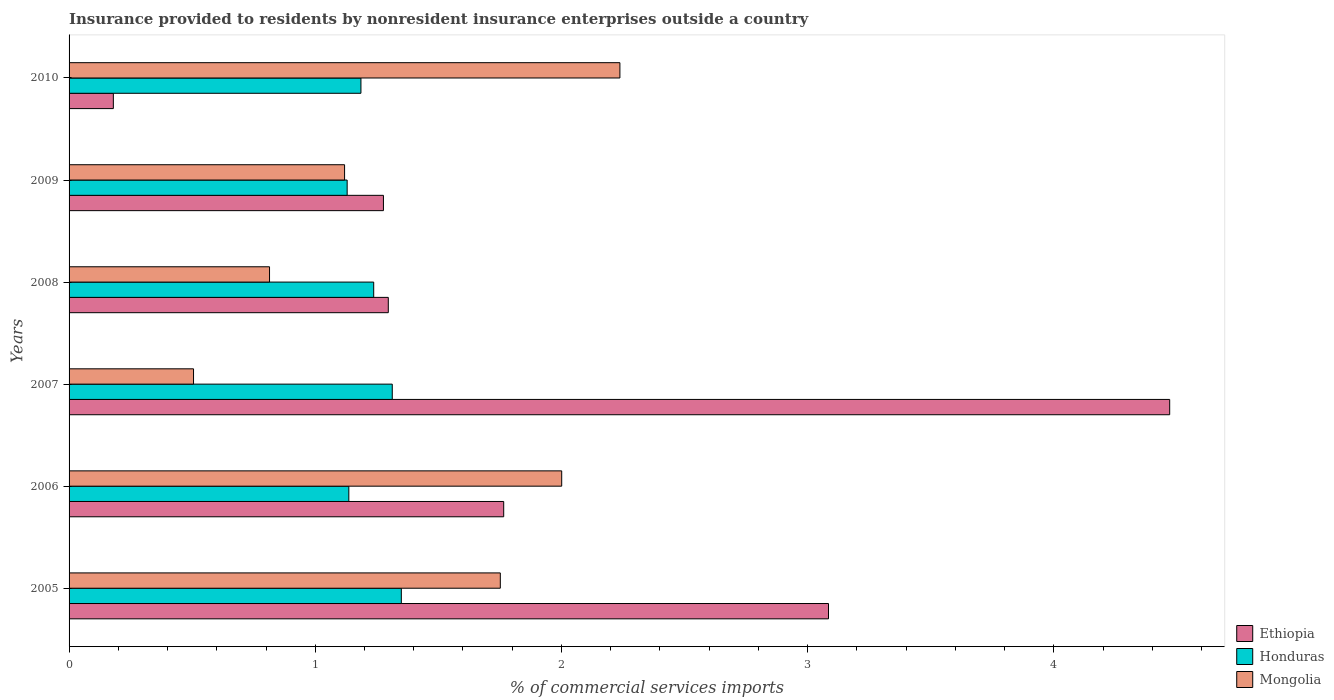How many groups of bars are there?
Your answer should be very brief. 6. Are the number of bars per tick equal to the number of legend labels?
Your answer should be very brief. Yes. In how many cases, is the number of bars for a given year not equal to the number of legend labels?
Your answer should be very brief. 0. What is the Insurance provided to residents in Honduras in 2005?
Your answer should be compact. 1.35. Across all years, what is the maximum Insurance provided to residents in Ethiopia?
Your answer should be compact. 4.47. Across all years, what is the minimum Insurance provided to residents in Ethiopia?
Provide a succinct answer. 0.18. In which year was the Insurance provided to residents in Ethiopia maximum?
Make the answer very short. 2007. In which year was the Insurance provided to residents in Honduras minimum?
Give a very brief answer. 2009. What is the total Insurance provided to residents in Ethiopia in the graph?
Ensure brevity in your answer.  12.07. What is the difference between the Insurance provided to residents in Mongolia in 2006 and that in 2007?
Your answer should be compact. 1.5. What is the difference between the Insurance provided to residents in Ethiopia in 2005 and the Insurance provided to residents in Honduras in 2008?
Provide a succinct answer. 1.85. What is the average Insurance provided to residents in Honduras per year?
Keep it short and to the point. 1.23. In the year 2006, what is the difference between the Insurance provided to residents in Mongolia and Insurance provided to residents in Honduras?
Provide a short and direct response. 0.86. In how many years, is the Insurance provided to residents in Ethiopia greater than 3 %?
Your answer should be very brief. 2. What is the ratio of the Insurance provided to residents in Mongolia in 2005 to that in 2009?
Your answer should be very brief. 1.57. What is the difference between the highest and the second highest Insurance provided to residents in Honduras?
Give a very brief answer. 0.04. What is the difference between the highest and the lowest Insurance provided to residents in Ethiopia?
Your response must be concise. 4.29. What does the 3rd bar from the top in 2009 represents?
Offer a terse response. Ethiopia. What does the 1st bar from the bottom in 2009 represents?
Give a very brief answer. Ethiopia. Is it the case that in every year, the sum of the Insurance provided to residents in Honduras and Insurance provided to residents in Mongolia is greater than the Insurance provided to residents in Ethiopia?
Your response must be concise. No. How many bars are there?
Offer a very short reply. 18. How many years are there in the graph?
Your response must be concise. 6. What is the difference between two consecutive major ticks on the X-axis?
Provide a succinct answer. 1. Are the values on the major ticks of X-axis written in scientific E-notation?
Offer a terse response. No. What is the title of the graph?
Keep it short and to the point. Insurance provided to residents by nonresident insurance enterprises outside a country. Does "Afghanistan" appear as one of the legend labels in the graph?
Give a very brief answer. No. What is the label or title of the X-axis?
Your response must be concise. % of commercial services imports. What is the % of commercial services imports of Ethiopia in 2005?
Ensure brevity in your answer.  3.08. What is the % of commercial services imports in Honduras in 2005?
Give a very brief answer. 1.35. What is the % of commercial services imports in Mongolia in 2005?
Give a very brief answer. 1.75. What is the % of commercial services imports in Ethiopia in 2006?
Provide a short and direct response. 1.77. What is the % of commercial services imports of Honduras in 2006?
Ensure brevity in your answer.  1.14. What is the % of commercial services imports of Mongolia in 2006?
Keep it short and to the point. 2. What is the % of commercial services imports in Ethiopia in 2007?
Offer a terse response. 4.47. What is the % of commercial services imports in Honduras in 2007?
Make the answer very short. 1.31. What is the % of commercial services imports in Mongolia in 2007?
Offer a very short reply. 0.51. What is the % of commercial services imports in Ethiopia in 2008?
Provide a short and direct response. 1.3. What is the % of commercial services imports in Honduras in 2008?
Keep it short and to the point. 1.24. What is the % of commercial services imports in Mongolia in 2008?
Make the answer very short. 0.81. What is the % of commercial services imports in Ethiopia in 2009?
Provide a succinct answer. 1.28. What is the % of commercial services imports of Honduras in 2009?
Your answer should be compact. 1.13. What is the % of commercial services imports of Mongolia in 2009?
Offer a very short reply. 1.12. What is the % of commercial services imports in Ethiopia in 2010?
Provide a short and direct response. 0.18. What is the % of commercial services imports in Honduras in 2010?
Your answer should be very brief. 1.19. What is the % of commercial services imports in Mongolia in 2010?
Your answer should be compact. 2.24. Across all years, what is the maximum % of commercial services imports of Ethiopia?
Your answer should be compact. 4.47. Across all years, what is the maximum % of commercial services imports of Honduras?
Provide a succinct answer. 1.35. Across all years, what is the maximum % of commercial services imports in Mongolia?
Give a very brief answer. 2.24. Across all years, what is the minimum % of commercial services imports in Ethiopia?
Your answer should be compact. 0.18. Across all years, what is the minimum % of commercial services imports of Honduras?
Offer a terse response. 1.13. Across all years, what is the minimum % of commercial services imports of Mongolia?
Provide a succinct answer. 0.51. What is the total % of commercial services imports in Ethiopia in the graph?
Offer a very short reply. 12.07. What is the total % of commercial services imports of Honduras in the graph?
Make the answer very short. 7.35. What is the total % of commercial services imports in Mongolia in the graph?
Your answer should be very brief. 8.43. What is the difference between the % of commercial services imports in Ethiopia in 2005 and that in 2006?
Your answer should be very brief. 1.32. What is the difference between the % of commercial services imports in Honduras in 2005 and that in 2006?
Your response must be concise. 0.21. What is the difference between the % of commercial services imports of Mongolia in 2005 and that in 2006?
Provide a short and direct response. -0.25. What is the difference between the % of commercial services imports of Ethiopia in 2005 and that in 2007?
Make the answer very short. -1.39. What is the difference between the % of commercial services imports of Honduras in 2005 and that in 2007?
Offer a very short reply. 0.04. What is the difference between the % of commercial services imports in Mongolia in 2005 and that in 2007?
Provide a short and direct response. 1.25. What is the difference between the % of commercial services imports in Ethiopia in 2005 and that in 2008?
Make the answer very short. 1.79. What is the difference between the % of commercial services imports of Honduras in 2005 and that in 2008?
Give a very brief answer. 0.11. What is the difference between the % of commercial services imports in Mongolia in 2005 and that in 2008?
Make the answer very short. 0.94. What is the difference between the % of commercial services imports in Ethiopia in 2005 and that in 2009?
Provide a succinct answer. 1.81. What is the difference between the % of commercial services imports of Honduras in 2005 and that in 2009?
Keep it short and to the point. 0.22. What is the difference between the % of commercial services imports of Mongolia in 2005 and that in 2009?
Make the answer very short. 0.63. What is the difference between the % of commercial services imports of Ethiopia in 2005 and that in 2010?
Provide a short and direct response. 2.9. What is the difference between the % of commercial services imports in Honduras in 2005 and that in 2010?
Provide a succinct answer. 0.16. What is the difference between the % of commercial services imports of Mongolia in 2005 and that in 2010?
Give a very brief answer. -0.49. What is the difference between the % of commercial services imports of Ethiopia in 2006 and that in 2007?
Your answer should be compact. -2.71. What is the difference between the % of commercial services imports of Honduras in 2006 and that in 2007?
Your answer should be compact. -0.18. What is the difference between the % of commercial services imports of Mongolia in 2006 and that in 2007?
Provide a short and direct response. 1.5. What is the difference between the % of commercial services imports in Ethiopia in 2006 and that in 2008?
Ensure brevity in your answer.  0.47. What is the difference between the % of commercial services imports in Honduras in 2006 and that in 2008?
Ensure brevity in your answer.  -0.1. What is the difference between the % of commercial services imports in Mongolia in 2006 and that in 2008?
Offer a terse response. 1.19. What is the difference between the % of commercial services imports in Ethiopia in 2006 and that in 2009?
Offer a very short reply. 0.49. What is the difference between the % of commercial services imports of Honduras in 2006 and that in 2009?
Your answer should be very brief. 0.01. What is the difference between the % of commercial services imports in Mongolia in 2006 and that in 2009?
Keep it short and to the point. 0.88. What is the difference between the % of commercial services imports in Ethiopia in 2006 and that in 2010?
Your response must be concise. 1.59. What is the difference between the % of commercial services imports in Honduras in 2006 and that in 2010?
Provide a succinct answer. -0.05. What is the difference between the % of commercial services imports of Mongolia in 2006 and that in 2010?
Offer a very short reply. -0.24. What is the difference between the % of commercial services imports of Ethiopia in 2007 and that in 2008?
Your answer should be compact. 3.17. What is the difference between the % of commercial services imports of Honduras in 2007 and that in 2008?
Offer a terse response. 0.08. What is the difference between the % of commercial services imports of Mongolia in 2007 and that in 2008?
Keep it short and to the point. -0.31. What is the difference between the % of commercial services imports of Ethiopia in 2007 and that in 2009?
Offer a terse response. 3.19. What is the difference between the % of commercial services imports in Honduras in 2007 and that in 2009?
Provide a succinct answer. 0.18. What is the difference between the % of commercial services imports in Mongolia in 2007 and that in 2009?
Offer a terse response. -0.61. What is the difference between the % of commercial services imports in Ethiopia in 2007 and that in 2010?
Provide a short and direct response. 4.29. What is the difference between the % of commercial services imports of Honduras in 2007 and that in 2010?
Ensure brevity in your answer.  0.13. What is the difference between the % of commercial services imports in Mongolia in 2007 and that in 2010?
Ensure brevity in your answer.  -1.73. What is the difference between the % of commercial services imports in Ethiopia in 2008 and that in 2009?
Give a very brief answer. 0.02. What is the difference between the % of commercial services imports in Honduras in 2008 and that in 2009?
Offer a very short reply. 0.11. What is the difference between the % of commercial services imports in Mongolia in 2008 and that in 2009?
Make the answer very short. -0.3. What is the difference between the % of commercial services imports in Ethiopia in 2008 and that in 2010?
Your response must be concise. 1.12. What is the difference between the % of commercial services imports of Honduras in 2008 and that in 2010?
Ensure brevity in your answer.  0.05. What is the difference between the % of commercial services imports of Mongolia in 2008 and that in 2010?
Offer a very short reply. -1.42. What is the difference between the % of commercial services imports of Ethiopia in 2009 and that in 2010?
Ensure brevity in your answer.  1.1. What is the difference between the % of commercial services imports in Honduras in 2009 and that in 2010?
Offer a very short reply. -0.06. What is the difference between the % of commercial services imports of Mongolia in 2009 and that in 2010?
Make the answer very short. -1.12. What is the difference between the % of commercial services imports in Ethiopia in 2005 and the % of commercial services imports in Honduras in 2006?
Keep it short and to the point. 1.95. What is the difference between the % of commercial services imports in Ethiopia in 2005 and the % of commercial services imports in Mongolia in 2006?
Your response must be concise. 1.08. What is the difference between the % of commercial services imports of Honduras in 2005 and the % of commercial services imports of Mongolia in 2006?
Keep it short and to the point. -0.65. What is the difference between the % of commercial services imports in Ethiopia in 2005 and the % of commercial services imports in Honduras in 2007?
Provide a short and direct response. 1.77. What is the difference between the % of commercial services imports of Ethiopia in 2005 and the % of commercial services imports of Mongolia in 2007?
Offer a terse response. 2.58. What is the difference between the % of commercial services imports in Honduras in 2005 and the % of commercial services imports in Mongolia in 2007?
Ensure brevity in your answer.  0.84. What is the difference between the % of commercial services imports of Ethiopia in 2005 and the % of commercial services imports of Honduras in 2008?
Provide a succinct answer. 1.85. What is the difference between the % of commercial services imports of Ethiopia in 2005 and the % of commercial services imports of Mongolia in 2008?
Offer a very short reply. 2.27. What is the difference between the % of commercial services imports in Honduras in 2005 and the % of commercial services imports in Mongolia in 2008?
Keep it short and to the point. 0.54. What is the difference between the % of commercial services imports of Ethiopia in 2005 and the % of commercial services imports of Honduras in 2009?
Offer a very short reply. 1.96. What is the difference between the % of commercial services imports of Ethiopia in 2005 and the % of commercial services imports of Mongolia in 2009?
Give a very brief answer. 1.97. What is the difference between the % of commercial services imports in Honduras in 2005 and the % of commercial services imports in Mongolia in 2009?
Your response must be concise. 0.23. What is the difference between the % of commercial services imports in Ethiopia in 2005 and the % of commercial services imports in Honduras in 2010?
Provide a succinct answer. 1.9. What is the difference between the % of commercial services imports of Ethiopia in 2005 and the % of commercial services imports of Mongolia in 2010?
Ensure brevity in your answer.  0.85. What is the difference between the % of commercial services imports in Honduras in 2005 and the % of commercial services imports in Mongolia in 2010?
Provide a short and direct response. -0.89. What is the difference between the % of commercial services imports in Ethiopia in 2006 and the % of commercial services imports in Honduras in 2007?
Your answer should be very brief. 0.45. What is the difference between the % of commercial services imports of Ethiopia in 2006 and the % of commercial services imports of Mongolia in 2007?
Ensure brevity in your answer.  1.26. What is the difference between the % of commercial services imports of Honduras in 2006 and the % of commercial services imports of Mongolia in 2007?
Provide a short and direct response. 0.63. What is the difference between the % of commercial services imports of Ethiopia in 2006 and the % of commercial services imports of Honduras in 2008?
Offer a very short reply. 0.53. What is the difference between the % of commercial services imports in Ethiopia in 2006 and the % of commercial services imports in Mongolia in 2008?
Keep it short and to the point. 0.95. What is the difference between the % of commercial services imports in Honduras in 2006 and the % of commercial services imports in Mongolia in 2008?
Make the answer very short. 0.32. What is the difference between the % of commercial services imports of Ethiopia in 2006 and the % of commercial services imports of Honduras in 2009?
Your answer should be very brief. 0.64. What is the difference between the % of commercial services imports of Ethiopia in 2006 and the % of commercial services imports of Mongolia in 2009?
Your answer should be compact. 0.65. What is the difference between the % of commercial services imports in Honduras in 2006 and the % of commercial services imports in Mongolia in 2009?
Your answer should be compact. 0.02. What is the difference between the % of commercial services imports of Ethiopia in 2006 and the % of commercial services imports of Honduras in 2010?
Your response must be concise. 0.58. What is the difference between the % of commercial services imports of Ethiopia in 2006 and the % of commercial services imports of Mongolia in 2010?
Offer a terse response. -0.47. What is the difference between the % of commercial services imports in Honduras in 2006 and the % of commercial services imports in Mongolia in 2010?
Your answer should be very brief. -1.1. What is the difference between the % of commercial services imports of Ethiopia in 2007 and the % of commercial services imports of Honduras in 2008?
Make the answer very short. 3.23. What is the difference between the % of commercial services imports of Ethiopia in 2007 and the % of commercial services imports of Mongolia in 2008?
Your answer should be very brief. 3.66. What is the difference between the % of commercial services imports of Honduras in 2007 and the % of commercial services imports of Mongolia in 2008?
Ensure brevity in your answer.  0.5. What is the difference between the % of commercial services imports in Ethiopia in 2007 and the % of commercial services imports in Honduras in 2009?
Offer a terse response. 3.34. What is the difference between the % of commercial services imports in Ethiopia in 2007 and the % of commercial services imports in Mongolia in 2009?
Give a very brief answer. 3.35. What is the difference between the % of commercial services imports of Honduras in 2007 and the % of commercial services imports of Mongolia in 2009?
Your response must be concise. 0.19. What is the difference between the % of commercial services imports in Ethiopia in 2007 and the % of commercial services imports in Honduras in 2010?
Offer a terse response. 3.29. What is the difference between the % of commercial services imports in Ethiopia in 2007 and the % of commercial services imports in Mongolia in 2010?
Your response must be concise. 2.23. What is the difference between the % of commercial services imports in Honduras in 2007 and the % of commercial services imports in Mongolia in 2010?
Offer a very short reply. -0.92. What is the difference between the % of commercial services imports in Ethiopia in 2008 and the % of commercial services imports in Honduras in 2009?
Keep it short and to the point. 0.17. What is the difference between the % of commercial services imports of Ethiopia in 2008 and the % of commercial services imports of Mongolia in 2009?
Make the answer very short. 0.18. What is the difference between the % of commercial services imports of Honduras in 2008 and the % of commercial services imports of Mongolia in 2009?
Keep it short and to the point. 0.12. What is the difference between the % of commercial services imports in Ethiopia in 2008 and the % of commercial services imports in Mongolia in 2010?
Your answer should be compact. -0.94. What is the difference between the % of commercial services imports of Honduras in 2008 and the % of commercial services imports of Mongolia in 2010?
Keep it short and to the point. -1. What is the difference between the % of commercial services imports in Ethiopia in 2009 and the % of commercial services imports in Honduras in 2010?
Your response must be concise. 0.09. What is the difference between the % of commercial services imports of Ethiopia in 2009 and the % of commercial services imports of Mongolia in 2010?
Ensure brevity in your answer.  -0.96. What is the difference between the % of commercial services imports of Honduras in 2009 and the % of commercial services imports of Mongolia in 2010?
Keep it short and to the point. -1.11. What is the average % of commercial services imports in Ethiopia per year?
Ensure brevity in your answer.  2.01. What is the average % of commercial services imports of Honduras per year?
Provide a succinct answer. 1.23. What is the average % of commercial services imports of Mongolia per year?
Your response must be concise. 1.4. In the year 2005, what is the difference between the % of commercial services imports in Ethiopia and % of commercial services imports in Honduras?
Keep it short and to the point. 1.74. In the year 2005, what is the difference between the % of commercial services imports in Ethiopia and % of commercial services imports in Mongolia?
Offer a very short reply. 1.33. In the year 2005, what is the difference between the % of commercial services imports in Honduras and % of commercial services imports in Mongolia?
Your answer should be compact. -0.4. In the year 2006, what is the difference between the % of commercial services imports in Ethiopia and % of commercial services imports in Honduras?
Offer a very short reply. 0.63. In the year 2006, what is the difference between the % of commercial services imports in Ethiopia and % of commercial services imports in Mongolia?
Provide a succinct answer. -0.24. In the year 2006, what is the difference between the % of commercial services imports in Honduras and % of commercial services imports in Mongolia?
Make the answer very short. -0.86. In the year 2007, what is the difference between the % of commercial services imports of Ethiopia and % of commercial services imports of Honduras?
Ensure brevity in your answer.  3.16. In the year 2007, what is the difference between the % of commercial services imports of Ethiopia and % of commercial services imports of Mongolia?
Offer a terse response. 3.96. In the year 2007, what is the difference between the % of commercial services imports in Honduras and % of commercial services imports in Mongolia?
Your answer should be very brief. 0.81. In the year 2008, what is the difference between the % of commercial services imports in Ethiopia and % of commercial services imports in Honduras?
Provide a succinct answer. 0.06. In the year 2008, what is the difference between the % of commercial services imports in Ethiopia and % of commercial services imports in Mongolia?
Give a very brief answer. 0.48. In the year 2008, what is the difference between the % of commercial services imports of Honduras and % of commercial services imports of Mongolia?
Ensure brevity in your answer.  0.42. In the year 2009, what is the difference between the % of commercial services imports of Ethiopia and % of commercial services imports of Honduras?
Offer a terse response. 0.15. In the year 2009, what is the difference between the % of commercial services imports in Ethiopia and % of commercial services imports in Mongolia?
Provide a succinct answer. 0.16. In the year 2009, what is the difference between the % of commercial services imports in Honduras and % of commercial services imports in Mongolia?
Your response must be concise. 0.01. In the year 2010, what is the difference between the % of commercial services imports in Ethiopia and % of commercial services imports in Honduras?
Provide a succinct answer. -1.01. In the year 2010, what is the difference between the % of commercial services imports of Ethiopia and % of commercial services imports of Mongolia?
Your answer should be compact. -2.06. In the year 2010, what is the difference between the % of commercial services imports in Honduras and % of commercial services imports in Mongolia?
Provide a succinct answer. -1.05. What is the ratio of the % of commercial services imports in Ethiopia in 2005 to that in 2006?
Provide a short and direct response. 1.75. What is the ratio of the % of commercial services imports in Honduras in 2005 to that in 2006?
Your answer should be compact. 1.19. What is the ratio of the % of commercial services imports in Mongolia in 2005 to that in 2006?
Your answer should be compact. 0.88. What is the ratio of the % of commercial services imports of Ethiopia in 2005 to that in 2007?
Ensure brevity in your answer.  0.69. What is the ratio of the % of commercial services imports of Honduras in 2005 to that in 2007?
Offer a terse response. 1.03. What is the ratio of the % of commercial services imports of Mongolia in 2005 to that in 2007?
Your response must be concise. 3.46. What is the ratio of the % of commercial services imports in Ethiopia in 2005 to that in 2008?
Your response must be concise. 2.38. What is the ratio of the % of commercial services imports of Honduras in 2005 to that in 2008?
Offer a very short reply. 1.09. What is the ratio of the % of commercial services imports of Mongolia in 2005 to that in 2008?
Give a very brief answer. 2.15. What is the ratio of the % of commercial services imports in Ethiopia in 2005 to that in 2009?
Make the answer very short. 2.42. What is the ratio of the % of commercial services imports in Honduras in 2005 to that in 2009?
Ensure brevity in your answer.  1.19. What is the ratio of the % of commercial services imports of Mongolia in 2005 to that in 2009?
Ensure brevity in your answer.  1.57. What is the ratio of the % of commercial services imports in Ethiopia in 2005 to that in 2010?
Offer a terse response. 17.15. What is the ratio of the % of commercial services imports of Honduras in 2005 to that in 2010?
Make the answer very short. 1.14. What is the ratio of the % of commercial services imports in Mongolia in 2005 to that in 2010?
Provide a short and direct response. 0.78. What is the ratio of the % of commercial services imports of Ethiopia in 2006 to that in 2007?
Provide a short and direct response. 0.39. What is the ratio of the % of commercial services imports of Honduras in 2006 to that in 2007?
Ensure brevity in your answer.  0.87. What is the ratio of the % of commercial services imports of Mongolia in 2006 to that in 2007?
Give a very brief answer. 3.96. What is the ratio of the % of commercial services imports in Ethiopia in 2006 to that in 2008?
Give a very brief answer. 1.36. What is the ratio of the % of commercial services imports of Honduras in 2006 to that in 2008?
Offer a very short reply. 0.92. What is the ratio of the % of commercial services imports of Mongolia in 2006 to that in 2008?
Keep it short and to the point. 2.46. What is the ratio of the % of commercial services imports of Ethiopia in 2006 to that in 2009?
Give a very brief answer. 1.38. What is the ratio of the % of commercial services imports in Honduras in 2006 to that in 2009?
Offer a terse response. 1.01. What is the ratio of the % of commercial services imports in Mongolia in 2006 to that in 2009?
Offer a very short reply. 1.79. What is the ratio of the % of commercial services imports in Ethiopia in 2006 to that in 2010?
Keep it short and to the point. 9.82. What is the ratio of the % of commercial services imports of Honduras in 2006 to that in 2010?
Offer a very short reply. 0.96. What is the ratio of the % of commercial services imports of Mongolia in 2006 to that in 2010?
Keep it short and to the point. 0.89. What is the ratio of the % of commercial services imports in Ethiopia in 2007 to that in 2008?
Your answer should be very brief. 3.45. What is the ratio of the % of commercial services imports in Honduras in 2007 to that in 2008?
Your answer should be compact. 1.06. What is the ratio of the % of commercial services imports of Mongolia in 2007 to that in 2008?
Keep it short and to the point. 0.62. What is the ratio of the % of commercial services imports of Ethiopia in 2007 to that in 2009?
Your answer should be compact. 3.5. What is the ratio of the % of commercial services imports of Honduras in 2007 to that in 2009?
Provide a short and direct response. 1.16. What is the ratio of the % of commercial services imports in Mongolia in 2007 to that in 2009?
Provide a succinct answer. 0.45. What is the ratio of the % of commercial services imports in Ethiopia in 2007 to that in 2010?
Your response must be concise. 24.86. What is the ratio of the % of commercial services imports of Honduras in 2007 to that in 2010?
Offer a terse response. 1.11. What is the ratio of the % of commercial services imports of Mongolia in 2007 to that in 2010?
Your answer should be compact. 0.23. What is the ratio of the % of commercial services imports in Ethiopia in 2008 to that in 2009?
Give a very brief answer. 1.02. What is the ratio of the % of commercial services imports in Honduras in 2008 to that in 2009?
Keep it short and to the point. 1.1. What is the ratio of the % of commercial services imports in Mongolia in 2008 to that in 2009?
Ensure brevity in your answer.  0.73. What is the ratio of the % of commercial services imports of Ethiopia in 2008 to that in 2010?
Make the answer very short. 7.21. What is the ratio of the % of commercial services imports in Honduras in 2008 to that in 2010?
Offer a terse response. 1.04. What is the ratio of the % of commercial services imports in Mongolia in 2008 to that in 2010?
Ensure brevity in your answer.  0.36. What is the ratio of the % of commercial services imports in Ethiopia in 2009 to that in 2010?
Keep it short and to the point. 7.1. What is the ratio of the % of commercial services imports in Honduras in 2009 to that in 2010?
Give a very brief answer. 0.95. What is the ratio of the % of commercial services imports of Mongolia in 2009 to that in 2010?
Your answer should be very brief. 0.5. What is the difference between the highest and the second highest % of commercial services imports in Ethiopia?
Your response must be concise. 1.39. What is the difference between the highest and the second highest % of commercial services imports in Honduras?
Offer a very short reply. 0.04. What is the difference between the highest and the second highest % of commercial services imports in Mongolia?
Your answer should be very brief. 0.24. What is the difference between the highest and the lowest % of commercial services imports of Ethiopia?
Keep it short and to the point. 4.29. What is the difference between the highest and the lowest % of commercial services imports of Honduras?
Offer a very short reply. 0.22. What is the difference between the highest and the lowest % of commercial services imports of Mongolia?
Ensure brevity in your answer.  1.73. 